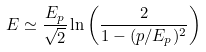<formula> <loc_0><loc_0><loc_500><loc_500>E \simeq \frac { E _ { p } } { \sqrt { 2 } } \ln \left ( \frac { 2 } { 1 - ( p / E _ { p } ) ^ { 2 } } \right )</formula> 